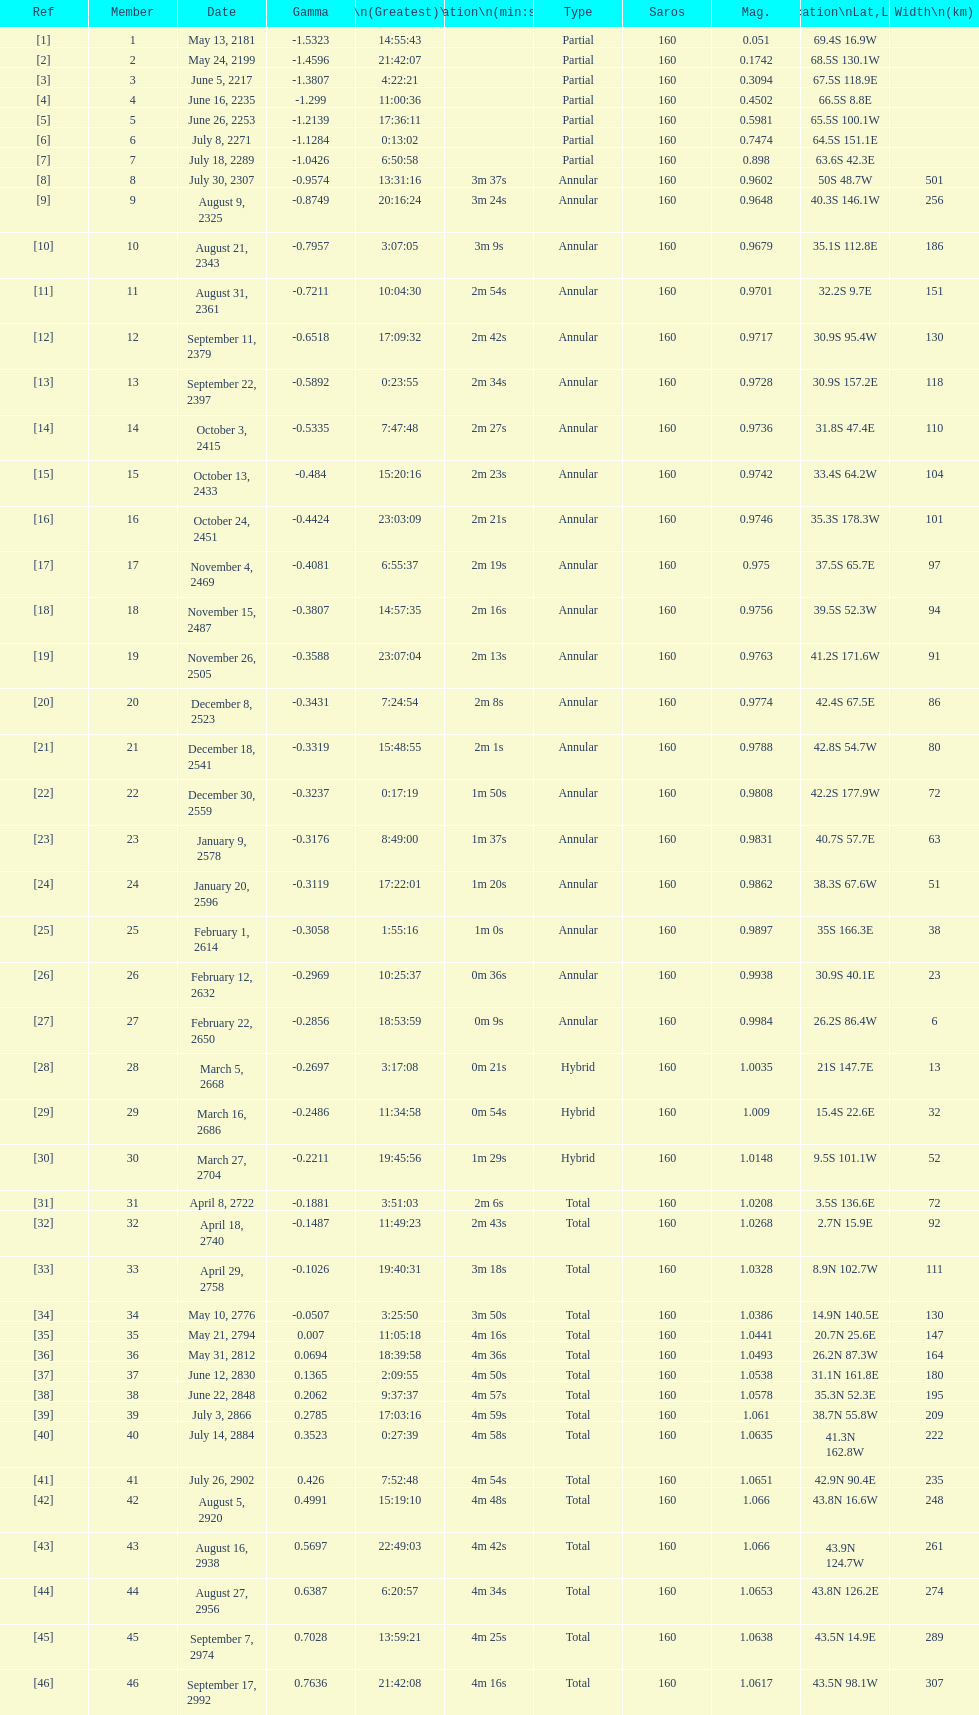Which one has a larger width, 8 or 21? 8. 